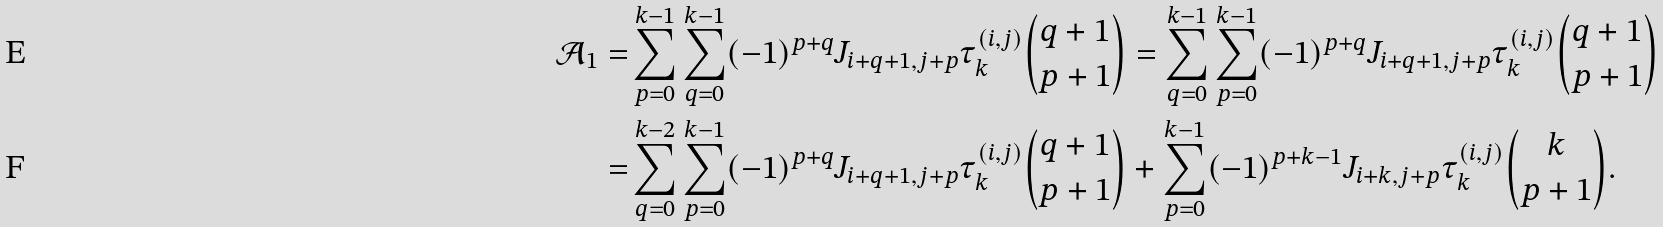Convert formula to latex. <formula><loc_0><loc_0><loc_500><loc_500>\mathcal { A } _ { 1 } = & \sum _ { p = 0 } ^ { k - 1 } \sum _ { q = 0 } ^ { k - 1 } ( - 1 ) ^ { p + q } J _ { i + q + 1 , j + p } \tau _ { k } ^ { ( i , j ) } \binom { q + 1 } { p + 1 } = \sum _ { q = 0 } ^ { k - 1 } \sum _ { p = 0 } ^ { k - 1 } ( - 1 ) ^ { p + q } J _ { i + q + 1 , j + p } \tau _ { k } ^ { ( i , j ) } \binom { q + 1 } { p + 1 } \\ = & \sum _ { q = 0 } ^ { k - 2 } \sum _ { p = 0 } ^ { k - 1 } ( - 1 ) ^ { p + q } J _ { i + q + 1 , j + p } \tau _ { k } ^ { ( i , j ) } \binom { q + 1 } { p + 1 } + \sum _ { p = 0 } ^ { k - 1 } ( - 1 ) ^ { p + k - 1 } J _ { i + k , j + p } \tau _ { k } ^ { ( i , j ) } \binom { k } { p + 1 } .</formula> 